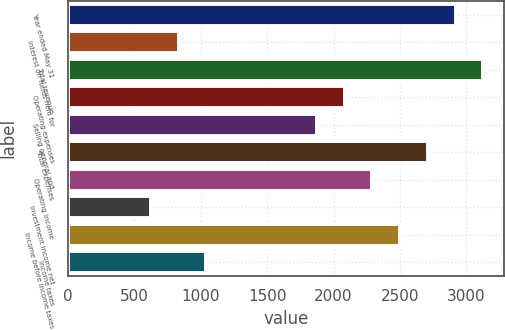<chart> <loc_0><loc_0><loc_500><loc_500><bar_chart><fcel>Year ended May 31<fcel>Interest on funds held for<fcel>Total revenue<fcel>Operating expenses<fcel>Selling general and<fcel>Total expenses<fcel>Operating income<fcel>Investment income net<fcel>Income before income taxes<fcel>Income taxes<nl><fcel>2917.58<fcel>834.48<fcel>3125.89<fcel>2084.34<fcel>1876.03<fcel>2709.27<fcel>2292.65<fcel>626.17<fcel>2500.96<fcel>1042.79<nl></chart> 